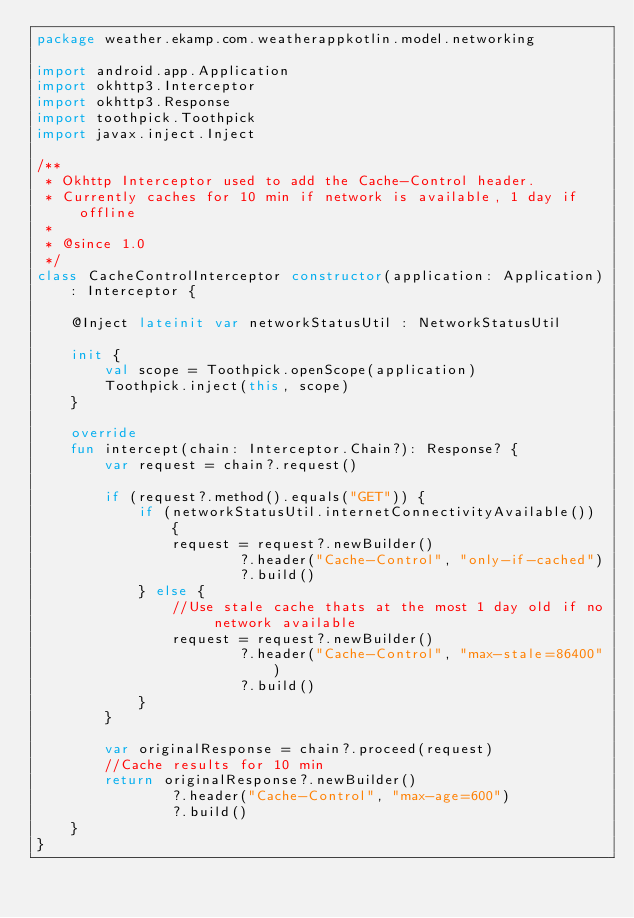Convert code to text. <code><loc_0><loc_0><loc_500><loc_500><_Kotlin_>package weather.ekamp.com.weatherappkotlin.model.networking

import android.app.Application
import okhttp3.Interceptor
import okhttp3.Response
import toothpick.Toothpick
import javax.inject.Inject

/**
 * Okhttp Interceptor used to add the Cache-Control header.
 * Currently caches for 10 min if network is available, 1 day if offline
 *
 * @since 1.0
 */
class CacheControlInterceptor constructor(application: Application): Interceptor {

    @Inject lateinit var networkStatusUtil : NetworkStatusUtil

    init {
        val scope = Toothpick.openScope(application)
        Toothpick.inject(this, scope)
    }

    override
    fun intercept(chain: Interceptor.Chain?): Response? {
        var request = chain?.request()

        if (request?.method().equals("GET")) {
            if (networkStatusUtil.internetConnectivityAvailable()) {
                request = request?.newBuilder()
                        ?.header("Cache-Control", "only-if-cached")
                        ?.build()
            } else {
                //Use stale cache thats at the most 1 day old if no network available
                request = request?.newBuilder()
                        ?.header("Cache-Control", "max-stale=86400")
                        ?.build()
            }
        }

        var originalResponse = chain?.proceed(request)
        //Cache results for 10 min
        return originalResponse?.newBuilder()
                ?.header("Cache-Control", "max-age=600")
                ?.build()
    }
}
</code> 